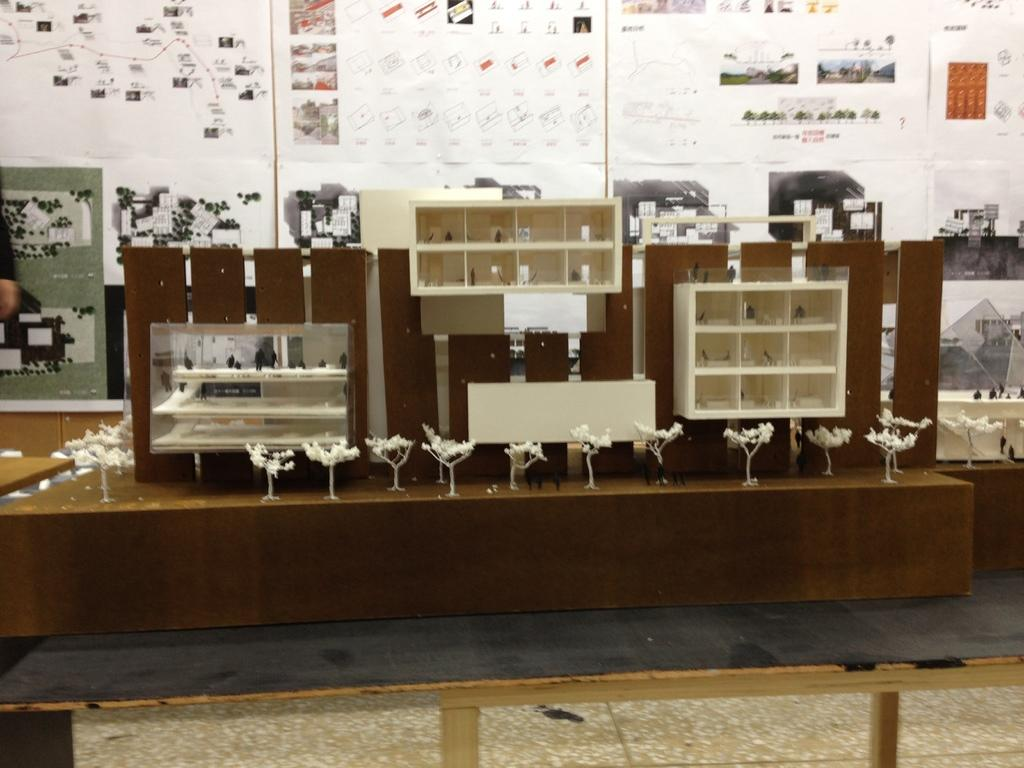What type of furniture is visible in the image? There are wooden shelves in the image. Where are the wooden shelves located? The wooden shelves are placed on a wooden surface. What can be seen in the background of the image? There are informational charts in the background of the image. What do the informational charts contain? The informational charts contain diagrams and text. What type of dinner is being served on the wooden shelves in the image? There is no dinner present in the image; it features wooden shelves with informational charts in the background. 